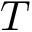<formula> <loc_0><loc_0><loc_500><loc_500>T</formula> 